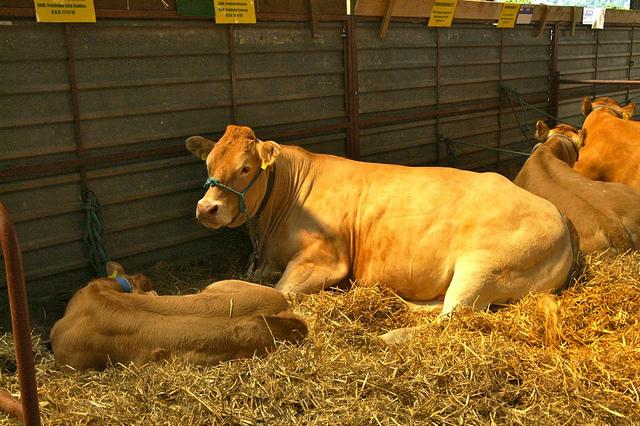What color is the handle tied around the sunlit cow's face? green 